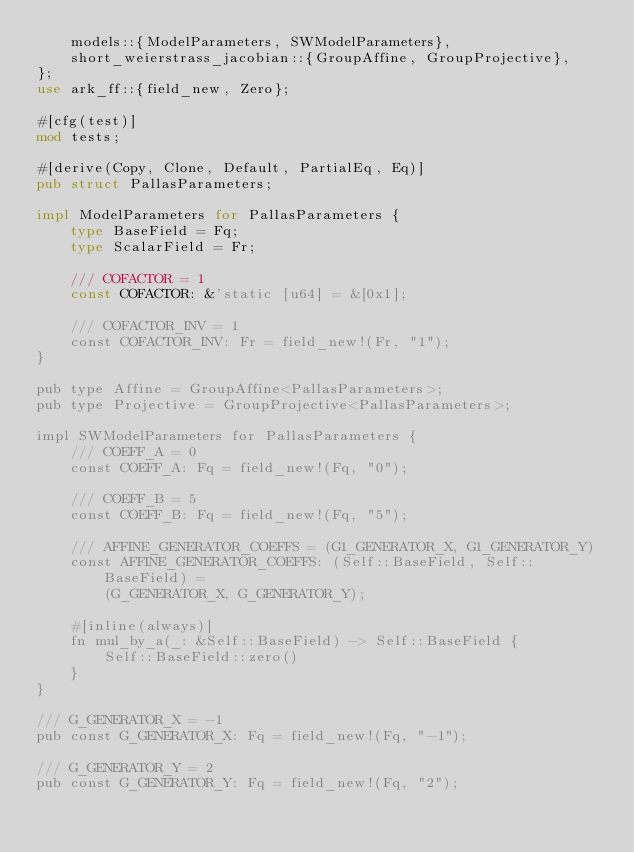<code> <loc_0><loc_0><loc_500><loc_500><_Rust_>    models::{ModelParameters, SWModelParameters},
    short_weierstrass_jacobian::{GroupAffine, GroupProjective},
};
use ark_ff::{field_new, Zero};

#[cfg(test)]
mod tests;

#[derive(Copy, Clone, Default, PartialEq, Eq)]
pub struct PallasParameters;

impl ModelParameters for PallasParameters {
    type BaseField = Fq;
    type ScalarField = Fr;

    /// COFACTOR = 1
    const COFACTOR: &'static [u64] = &[0x1];

    /// COFACTOR_INV = 1
    const COFACTOR_INV: Fr = field_new!(Fr, "1");
}

pub type Affine = GroupAffine<PallasParameters>;
pub type Projective = GroupProjective<PallasParameters>;

impl SWModelParameters for PallasParameters {
    /// COEFF_A = 0
    const COEFF_A: Fq = field_new!(Fq, "0");

    /// COEFF_B = 5
    const COEFF_B: Fq = field_new!(Fq, "5");

    /// AFFINE_GENERATOR_COEFFS = (G1_GENERATOR_X, G1_GENERATOR_Y)
    const AFFINE_GENERATOR_COEFFS: (Self::BaseField, Self::BaseField) =
        (G_GENERATOR_X, G_GENERATOR_Y);

    #[inline(always)]
    fn mul_by_a(_: &Self::BaseField) -> Self::BaseField {
        Self::BaseField::zero()
    }
}

/// G_GENERATOR_X = -1
pub const G_GENERATOR_X: Fq = field_new!(Fq, "-1");

/// G_GENERATOR_Y = 2
pub const G_GENERATOR_Y: Fq = field_new!(Fq, "2");
</code> 